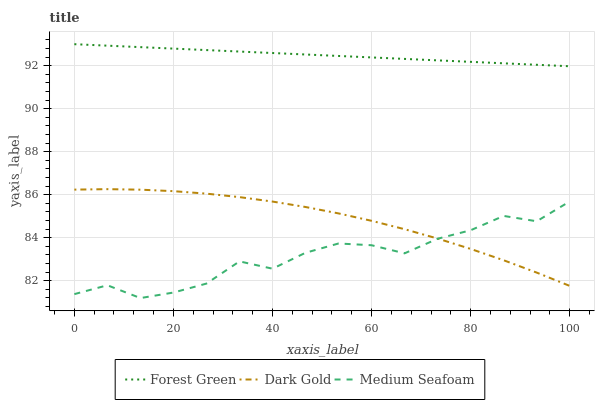Does Medium Seafoam have the minimum area under the curve?
Answer yes or no. Yes. Does Forest Green have the maximum area under the curve?
Answer yes or no. Yes. Does Dark Gold have the minimum area under the curve?
Answer yes or no. No. Does Dark Gold have the maximum area under the curve?
Answer yes or no. No. Is Forest Green the smoothest?
Answer yes or no. Yes. Is Medium Seafoam the roughest?
Answer yes or no. Yes. Is Dark Gold the smoothest?
Answer yes or no. No. Is Dark Gold the roughest?
Answer yes or no. No. Does Medium Seafoam have the lowest value?
Answer yes or no. Yes. Does Dark Gold have the lowest value?
Answer yes or no. No. Does Forest Green have the highest value?
Answer yes or no. Yes. Does Dark Gold have the highest value?
Answer yes or no. No. Is Dark Gold less than Forest Green?
Answer yes or no. Yes. Is Forest Green greater than Dark Gold?
Answer yes or no. Yes. Does Dark Gold intersect Medium Seafoam?
Answer yes or no. Yes. Is Dark Gold less than Medium Seafoam?
Answer yes or no. No. Is Dark Gold greater than Medium Seafoam?
Answer yes or no. No. Does Dark Gold intersect Forest Green?
Answer yes or no. No. 